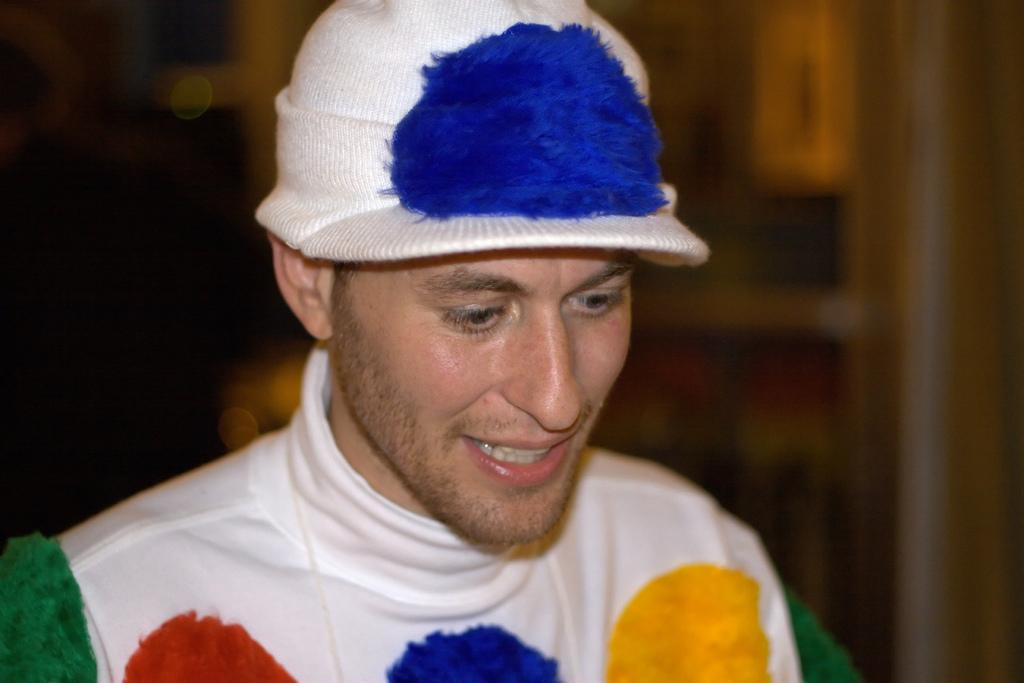What is the main subject of the image? There is a man in the image. Can you describe the man's attire? The man is wearing a cap. What type of seed is the man planting in the image? There is no seed or planting activity present in the image; it only features a man wearing a cap. How many lizards can be seen interacting with the man in the image? There are no lizards present in the image. 